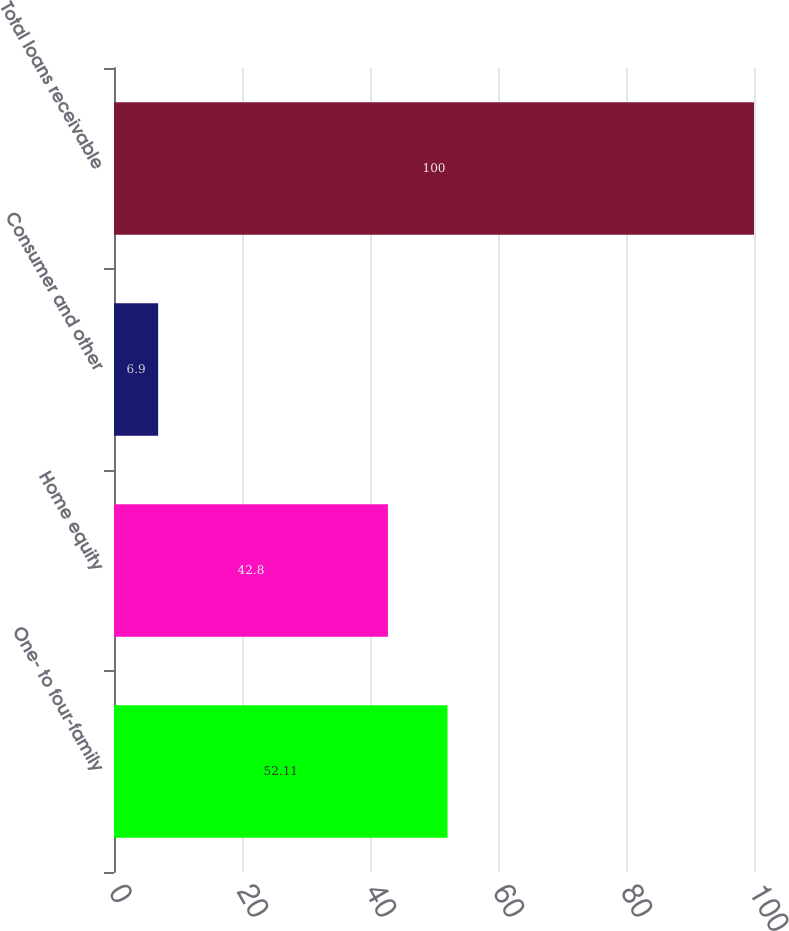<chart> <loc_0><loc_0><loc_500><loc_500><bar_chart><fcel>One- to four-family<fcel>Home equity<fcel>Consumer and other<fcel>Total loans receivable<nl><fcel>52.11<fcel>42.8<fcel>6.9<fcel>100<nl></chart> 